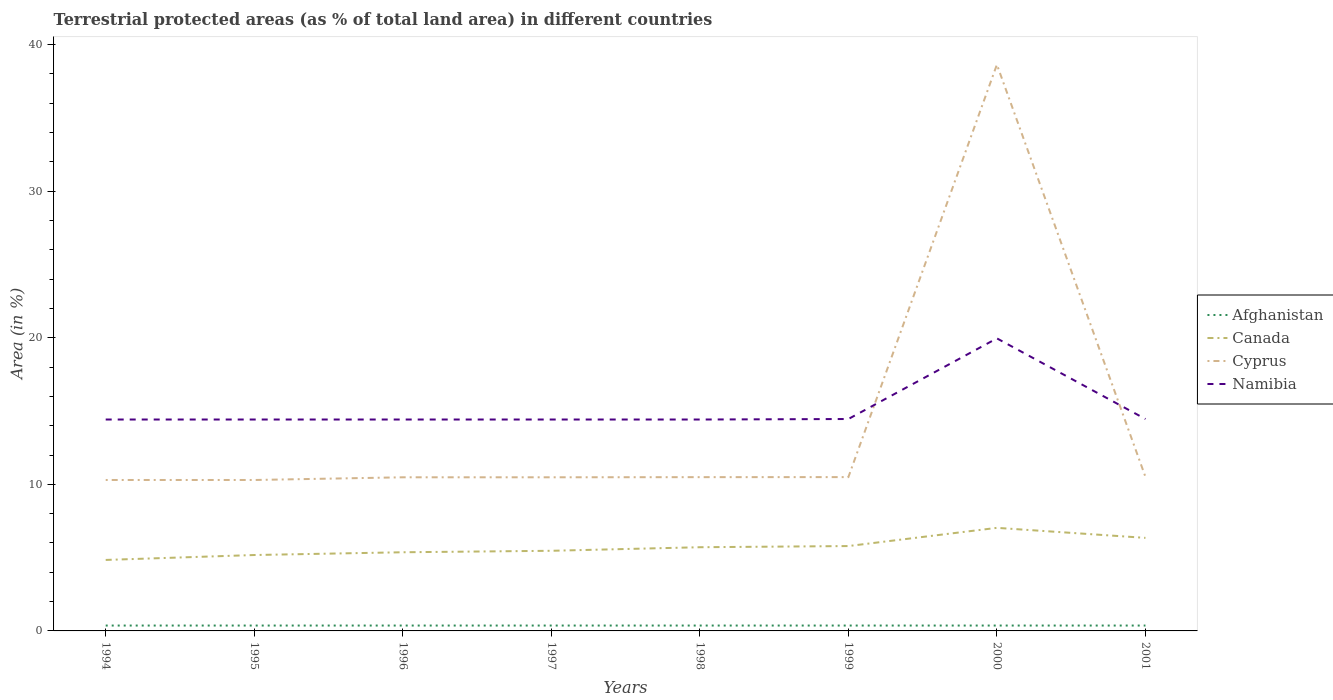Is the number of lines equal to the number of legend labels?
Your response must be concise. Yes. Across all years, what is the maximum percentage of terrestrial protected land in Cyprus?
Your answer should be compact. 10.3. In which year was the percentage of terrestrial protected land in Canada maximum?
Offer a very short reply. 1994. What is the total percentage of terrestrial protected land in Namibia in the graph?
Provide a short and direct response. -0.03. What is the difference between the highest and the second highest percentage of terrestrial protected land in Canada?
Ensure brevity in your answer.  2.19. Is the percentage of terrestrial protected land in Cyprus strictly greater than the percentage of terrestrial protected land in Namibia over the years?
Make the answer very short. No. How many years are there in the graph?
Give a very brief answer. 8. What is the difference between two consecutive major ticks on the Y-axis?
Your response must be concise. 10. Does the graph contain grids?
Offer a very short reply. No. Where does the legend appear in the graph?
Your answer should be compact. Center right. How are the legend labels stacked?
Provide a short and direct response. Vertical. What is the title of the graph?
Ensure brevity in your answer.  Terrestrial protected areas (as % of total land area) in different countries. Does "Myanmar" appear as one of the legend labels in the graph?
Your answer should be compact. No. What is the label or title of the Y-axis?
Make the answer very short. Area (in %). What is the Area (in %) in Afghanistan in 1994?
Provide a short and direct response. 0.37. What is the Area (in %) of Canada in 1994?
Offer a very short reply. 4.84. What is the Area (in %) of Cyprus in 1994?
Offer a terse response. 10.3. What is the Area (in %) of Namibia in 1994?
Provide a succinct answer. 14.42. What is the Area (in %) of Afghanistan in 1995?
Provide a succinct answer. 0.37. What is the Area (in %) in Canada in 1995?
Provide a short and direct response. 5.18. What is the Area (in %) in Cyprus in 1995?
Your answer should be very brief. 10.3. What is the Area (in %) in Namibia in 1995?
Give a very brief answer. 14.42. What is the Area (in %) of Afghanistan in 1996?
Provide a short and direct response. 0.37. What is the Area (in %) in Canada in 1996?
Offer a very short reply. 5.37. What is the Area (in %) of Cyprus in 1996?
Make the answer very short. 10.48. What is the Area (in %) of Namibia in 1996?
Keep it short and to the point. 14.42. What is the Area (in %) in Afghanistan in 1997?
Your answer should be very brief. 0.37. What is the Area (in %) in Canada in 1997?
Offer a very short reply. 5.47. What is the Area (in %) in Cyprus in 1997?
Give a very brief answer. 10.48. What is the Area (in %) in Namibia in 1997?
Offer a terse response. 14.42. What is the Area (in %) in Afghanistan in 1998?
Ensure brevity in your answer.  0.37. What is the Area (in %) in Canada in 1998?
Give a very brief answer. 5.71. What is the Area (in %) of Cyprus in 1998?
Your response must be concise. 10.49. What is the Area (in %) of Namibia in 1998?
Ensure brevity in your answer.  14.42. What is the Area (in %) of Afghanistan in 1999?
Your response must be concise. 0.37. What is the Area (in %) of Canada in 1999?
Offer a terse response. 5.79. What is the Area (in %) of Cyprus in 1999?
Provide a short and direct response. 10.49. What is the Area (in %) of Namibia in 1999?
Offer a terse response. 14.46. What is the Area (in %) of Afghanistan in 2000?
Your response must be concise. 0.37. What is the Area (in %) of Canada in 2000?
Make the answer very short. 7.03. What is the Area (in %) of Cyprus in 2000?
Ensure brevity in your answer.  38.63. What is the Area (in %) in Namibia in 2000?
Keep it short and to the point. 19.96. What is the Area (in %) of Afghanistan in 2001?
Ensure brevity in your answer.  0.37. What is the Area (in %) of Canada in 2001?
Your answer should be compact. 6.35. What is the Area (in %) in Cyprus in 2001?
Your answer should be very brief. 10.51. What is the Area (in %) in Namibia in 2001?
Provide a short and direct response. 14.46. Across all years, what is the maximum Area (in %) of Afghanistan?
Provide a short and direct response. 0.37. Across all years, what is the maximum Area (in %) in Canada?
Your response must be concise. 7.03. Across all years, what is the maximum Area (in %) of Cyprus?
Provide a short and direct response. 38.63. Across all years, what is the maximum Area (in %) in Namibia?
Provide a short and direct response. 19.96. Across all years, what is the minimum Area (in %) in Afghanistan?
Keep it short and to the point. 0.37. Across all years, what is the minimum Area (in %) in Canada?
Give a very brief answer. 4.84. Across all years, what is the minimum Area (in %) of Cyprus?
Offer a terse response. 10.3. Across all years, what is the minimum Area (in %) in Namibia?
Provide a succinct answer. 14.42. What is the total Area (in %) of Afghanistan in the graph?
Make the answer very short. 2.94. What is the total Area (in %) of Canada in the graph?
Offer a very short reply. 45.73. What is the total Area (in %) in Cyprus in the graph?
Keep it short and to the point. 111.67. What is the total Area (in %) in Namibia in the graph?
Your answer should be compact. 120.97. What is the difference between the Area (in %) of Canada in 1994 and that in 1995?
Provide a succinct answer. -0.34. What is the difference between the Area (in %) in Afghanistan in 1994 and that in 1996?
Ensure brevity in your answer.  0. What is the difference between the Area (in %) in Canada in 1994 and that in 1996?
Make the answer very short. -0.52. What is the difference between the Area (in %) of Cyprus in 1994 and that in 1996?
Provide a short and direct response. -0.18. What is the difference between the Area (in %) of Afghanistan in 1994 and that in 1997?
Offer a terse response. 0. What is the difference between the Area (in %) in Canada in 1994 and that in 1997?
Offer a terse response. -0.62. What is the difference between the Area (in %) of Cyprus in 1994 and that in 1997?
Your answer should be very brief. -0.18. What is the difference between the Area (in %) of Afghanistan in 1994 and that in 1998?
Offer a very short reply. 0. What is the difference between the Area (in %) of Canada in 1994 and that in 1998?
Give a very brief answer. -0.87. What is the difference between the Area (in %) of Cyprus in 1994 and that in 1998?
Keep it short and to the point. -0.19. What is the difference between the Area (in %) in Namibia in 1994 and that in 1998?
Offer a terse response. 0. What is the difference between the Area (in %) of Canada in 1994 and that in 1999?
Your answer should be very brief. -0.95. What is the difference between the Area (in %) in Cyprus in 1994 and that in 1999?
Ensure brevity in your answer.  -0.2. What is the difference between the Area (in %) of Namibia in 1994 and that in 1999?
Ensure brevity in your answer.  -0.03. What is the difference between the Area (in %) in Afghanistan in 1994 and that in 2000?
Keep it short and to the point. -0. What is the difference between the Area (in %) of Canada in 1994 and that in 2000?
Offer a terse response. -2.19. What is the difference between the Area (in %) in Cyprus in 1994 and that in 2000?
Keep it short and to the point. -28.33. What is the difference between the Area (in %) of Namibia in 1994 and that in 2000?
Your response must be concise. -5.54. What is the difference between the Area (in %) in Afghanistan in 1994 and that in 2001?
Your answer should be compact. 0. What is the difference between the Area (in %) of Canada in 1994 and that in 2001?
Provide a succinct answer. -1.51. What is the difference between the Area (in %) of Cyprus in 1994 and that in 2001?
Provide a succinct answer. -0.21. What is the difference between the Area (in %) in Namibia in 1994 and that in 2001?
Your answer should be compact. -0.03. What is the difference between the Area (in %) in Afghanistan in 1995 and that in 1996?
Offer a terse response. 0. What is the difference between the Area (in %) of Canada in 1995 and that in 1996?
Provide a short and direct response. -0.19. What is the difference between the Area (in %) of Cyprus in 1995 and that in 1996?
Make the answer very short. -0.18. What is the difference between the Area (in %) of Afghanistan in 1995 and that in 1997?
Offer a very short reply. 0. What is the difference between the Area (in %) of Canada in 1995 and that in 1997?
Make the answer very short. -0.29. What is the difference between the Area (in %) of Cyprus in 1995 and that in 1997?
Offer a very short reply. -0.18. What is the difference between the Area (in %) in Afghanistan in 1995 and that in 1998?
Keep it short and to the point. 0. What is the difference between the Area (in %) of Canada in 1995 and that in 1998?
Your response must be concise. -0.53. What is the difference between the Area (in %) in Cyprus in 1995 and that in 1998?
Your answer should be very brief. -0.19. What is the difference between the Area (in %) of Namibia in 1995 and that in 1998?
Provide a succinct answer. 0. What is the difference between the Area (in %) in Afghanistan in 1995 and that in 1999?
Your answer should be very brief. 0. What is the difference between the Area (in %) of Canada in 1995 and that in 1999?
Ensure brevity in your answer.  -0.61. What is the difference between the Area (in %) of Cyprus in 1995 and that in 1999?
Your answer should be very brief. -0.2. What is the difference between the Area (in %) of Namibia in 1995 and that in 1999?
Make the answer very short. -0.03. What is the difference between the Area (in %) in Canada in 1995 and that in 2000?
Make the answer very short. -1.85. What is the difference between the Area (in %) of Cyprus in 1995 and that in 2000?
Provide a short and direct response. -28.33. What is the difference between the Area (in %) of Namibia in 1995 and that in 2000?
Make the answer very short. -5.54. What is the difference between the Area (in %) in Canada in 1995 and that in 2001?
Ensure brevity in your answer.  -1.17. What is the difference between the Area (in %) in Cyprus in 1995 and that in 2001?
Your response must be concise. -0.21. What is the difference between the Area (in %) of Namibia in 1995 and that in 2001?
Ensure brevity in your answer.  -0.03. What is the difference between the Area (in %) in Afghanistan in 1996 and that in 1997?
Your answer should be very brief. 0. What is the difference between the Area (in %) of Canada in 1996 and that in 1997?
Your answer should be very brief. -0.1. What is the difference between the Area (in %) in Cyprus in 1996 and that in 1997?
Offer a terse response. 0. What is the difference between the Area (in %) in Namibia in 1996 and that in 1997?
Your response must be concise. 0. What is the difference between the Area (in %) in Afghanistan in 1996 and that in 1998?
Offer a very short reply. 0. What is the difference between the Area (in %) of Canada in 1996 and that in 1998?
Make the answer very short. -0.34. What is the difference between the Area (in %) in Cyprus in 1996 and that in 1998?
Provide a short and direct response. -0.01. What is the difference between the Area (in %) of Afghanistan in 1996 and that in 1999?
Your response must be concise. 0. What is the difference between the Area (in %) in Canada in 1996 and that in 1999?
Offer a very short reply. -0.42. What is the difference between the Area (in %) in Cyprus in 1996 and that in 1999?
Provide a short and direct response. -0.01. What is the difference between the Area (in %) of Namibia in 1996 and that in 1999?
Provide a short and direct response. -0.03. What is the difference between the Area (in %) of Afghanistan in 1996 and that in 2000?
Keep it short and to the point. -0. What is the difference between the Area (in %) in Canada in 1996 and that in 2000?
Your response must be concise. -1.67. What is the difference between the Area (in %) in Cyprus in 1996 and that in 2000?
Give a very brief answer. -28.15. What is the difference between the Area (in %) of Namibia in 1996 and that in 2000?
Ensure brevity in your answer.  -5.54. What is the difference between the Area (in %) in Canada in 1996 and that in 2001?
Offer a very short reply. -0.98. What is the difference between the Area (in %) of Cyprus in 1996 and that in 2001?
Provide a short and direct response. -0.03. What is the difference between the Area (in %) of Namibia in 1996 and that in 2001?
Offer a very short reply. -0.03. What is the difference between the Area (in %) in Afghanistan in 1997 and that in 1998?
Provide a succinct answer. 0. What is the difference between the Area (in %) in Canada in 1997 and that in 1998?
Your response must be concise. -0.24. What is the difference between the Area (in %) in Cyprus in 1997 and that in 1998?
Make the answer very short. -0.01. What is the difference between the Area (in %) of Canada in 1997 and that in 1999?
Make the answer very short. -0.32. What is the difference between the Area (in %) in Cyprus in 1997 and that in 1999?
Provide a succinct answer. -0.01. What is the difference between the Area (in %) in Namibia in 1997 and that in 1999?
Provide a succinct answer. -0.03. What is the difference between the Area (in %) in Canada in 1997 and that in 2000?
Make the answer very short. -1.56. What is the difference between the Area (in %) in Cyprus in 1997 and that in 2000?
Ensure brevity in your answer.  -28.15. What is the difference between the Area (in %) in Namibia in 1997 and that in 2000?
Give a very brief answer. -5.54. What is the difference between the Area (in %) of Afghanistan in 1997 and that in 2001?
Provide a short and direct response. 0. What is the difference between the Area (in %) in Canada in 1997 and that in 2001?
Your answer should be very brief. -0.88. What is the difference between the Area (in %) in Cyprus in 1997 and that in 2001?
Keep it short and to the point. -0.03. What is the difference between the Area (in %) in Namibia in 1997 and that in 2001?
Provide a short and direct response. -0.03. What is the difference between the Area (in %) of Afghanistan in 1998 and that in 1999?
Make the answer very short. 0. What is the difference between the Area (in %) in Canada in 1998 and that in 1999?
Provide a succinct answer. -0.08. What is the difference between the Area (in %) in Cyprus in 1998 and that in 1999?
Offer a terse response. -0. What is the difference between the Area (in %) in Namibia in 1998 and that in 1999?
Your response must be concise. -0.03. What is the difference between the Area (in %) in Canada in 1998 and that in 2000?
Your answer should be very brief. -1.32. What is the difference between the Area (in %) in Cyprus in 1998 and that in 2000?
Provide a succinct answer. -28.14. What is the difference between the Area (in %) in Namibia in 1998 and that in 2000?
Your answer should be compact. -5.54. What is the difference between the Area (in %) of Afghanistan in 1998 and that in 2001?
Keep it short and to the point. 0. What is the difference between the Area (in %) in Canada in 1998 and that in 2001?
Your response must be concise. -0.64. What is the difference between the Area (in %) of Cyprus in 1998 and that in 2001?
Your answer should be very brief. -0.02. What is the difference between the Area (in %) of Namibia in 1998 and that in 2001?
Provide a short and direct response. -0.03. What is the difference between the Area (in %) of Afghanistan in 1999 and that in 2000?
Your answer should be very brief. -0. What is the difference between the Area (in %) in Canada in 1999 and that in 2000?
Give a very brief answer. -1.24. What is the difference between the Area (in %) of Cyprus in 1999 and that in 2000?
Provide a short and direct response. -28.14. What is the difference between the Area (in %) in Namibia in 1999 and that in 2000?
Your answer should be very brief. -5.5. What is the difference between the Area (in %) in Canada in 1999 and that in 2001?
Offer a terse response. -0.56. What is the difference between the Area (in %) of Cyprus in 1999 and that in 2001?
Your answer should be compact. -0.02. What is the difference between the Area (in %) in Namibia in 1999 and that in 2001?
Your answer should be very brief. 0. What is the difference between the Area (in %) in Canada in 2000 and that in 2001?
Offer a terse response. 0.68. What is the difference between the Area (in %) in Cyprus in 2000 and that in 2001?
Your answer should be very brief. 28.12. What is the difference between the Area (in %) in Namibia in 2000 and that in 2001?
Your answer should be very brief. 5.5. What is the difference between the Area (in %) of Afghanistan in 1994 and the Area (in %) of Canada in 1995?
Make the answer very short. -4.81. What is the difference between the Area (in %) of Afghanistan in 1994 and the Area (in %) of Cyprus in 1995?
Provide a succinct answer. -9.93. What is the difference between the Area (in %) of Afghanistan in 1994 and the Area (in %) of Namibia in 1995?
Provide a short and direct response. -14.05. What is the difference between the Area (in %) of Canada in 1994 and the Area (in %) of Cyprus in 1995?
Your answer should be compact. -5.45. What is the difference between the Area (in %) of Canada in 1994 and the Area (in %) of Namibia in 1995?
Ensure brevity in your answer.  -9.58. What is the difference between the Area (in %) of Cyprus in 1994 and the Area (in %) of Namibia in 1995?
Keep it short and to the point. -4.12. What is the difference between the Area (in %) in Afghanistan in 1994 and the Area (in %) in Canada in 1996?
Your answer should be very brief. -5. What is the difference between the Area (in %) in Afghanistan in 1994 and the Area (in %) in Cyprus in 1996?
Provide a succinct answer. -10.11. What is the difference between the Area (in %) of Afghanistan in 1994 and the Area (in %) of Namibia in 1996?
Provide a succinct answer. -14.05. What is the difference between the Area (in %) of Canada in 1994 and the Area (in %) of Cyprus in 1996?
Ensure brevity in your answer.  -5.64. What is the difference between the Area (in %) of Canada in 1994 and the Area (in %) of Namibia in 1996?
Your answer should be compact. -9.58. What is the difference between the Area (in %) in Cyprus in 1994 and the Area (in %) in Namibia in 1996?
Provide a short and direct response. -4.12. What is the difference between the Area (in %) of Afghanistan in 1994 and the Area (in %) of Canada in 1997?
Keep it short and to the point. -5.1. What is the difference between the Area (in %) of Afghanistan in 1994 and the Area (in %) of Cyprus in 1997?
Your answer should be compact. -10.11. What is the difference between the Area (in %) of Afghanistan in 1994 and the Area (in %) of Namibia in 1997?
Make the answer very short. -14.05. What is the difference between the Area (in %) of Canada in 1994 and the Area (in %) of Cyprus in 1997?
Your answer should be very brief. -5.64. What is the difference between the Area (in %) of Canada in 1994 and the Area (in %) of Namibia in 1997?
Your response must be concise. -9.58. What is the difference between the Area (in %) of Cyprus in 1994 and the Area (in %) of Namibia in 1997?
Ensure brevity in your answer.  -4.12. What is the difference between the Area (in %) of Afghanistan in 1994 and the Area (in %) of Canada in 1998?
Provide a short and direct response. -5.34. What is the difference between the Area (in %) of Afghanistan in 1994 and the Area (in %) of Cyprus in 1998?
Your answer should be compact. -10.12. What is the difference between the Area (in %) in Afghanistan in 1994 and the Area (in %) in Namibia in 1998?
Make the answer very short. -14.05. What is the difference between the Area (in %) of Canada in 1994 and the Area (in %) of Cyprus in 1998?
Your answer should be very brief. -5.65. What is the difference between the Area (in %) in Canada in 1994 and the Area (in %) in Namibia in 1998?
Your response must be concise. -9.58. What is the difference between the Area (in %) in Cyprus in 1994 and the Area (in %) in Namibia in 1998?
Ensure brevity in your answer.  -4.12. What is the difference between the Area (in %) in Afghanistan in 1994 and the Area (in %) in Canada in 1999?
Your response must be concise. -5.42. What is the difference between the Area (in %) in Afghanistan in 1994 and the Area (in %) in Cyprus in 1999?
Keep it short and to the point. -10.13. What is the difference between the Area (in %) of Afghanistan in 1994 and the Area (in %) of Namibia in 1999?
Make the answer very short. -14.09. What is the difference between the Area (in %) in Canada in 1994 and the Area (in %) in Cyprus in 1999?
Your answer should be very brief. -5.65. What is the difference between the Area (in %) in Canada in 1994 and the Area (in %) in Namibia in 1999?
Your answer should be very brief. -9.61. What is the difference between the Area (in %) of Cyprus in 1994 and the Area (in %) of Namibia in 1999?
Ensure brevity in your answer.  -4.16. What is the difference between the Area (in %) in Afghanistan in 1994 and the Area (in %) in Canada in 2000?
Provide a succinct answer. -6.66. What is the difference between the Area (in %) of Afghanistan in 1994 and the Area (in %) of Cyprus in 2000?
Give a very brief answer. -38.26. What is the difference between the Area (in %) in Afghanistan in 1994 and the Area (in %) in Namibia in 2000?
Your answer should be compact. -19.59. What is the difference between the Area (in %) of Canada in 1994 and the Area (in %) of Cyprus in 2000?
Give a very brief answer. -33.79. What is the difference between the Area (in %) of Canada in 1994 and the Area (in %) of Namibia in 2000?
Your answer should be very brief. -15.11. What is the difference between the Area (in %) of Cyprus in 1994 and the Area (in %) of Namibia in 2000?
Keep it short and to the point. -9.66. What is the difference between the Area (in %) in Afghanistan in 1994 and the Area (in %) in Canada in 2001?
Provide a short and direct response. -5.98. What is the difference between the Area (in %) of Afghanistan in 1994 and the Area (in %) of Cyprus in 2001?
Offer a very short reply. -10.14. What is the difference between the Area (in %) of Afghanistan in 1994 and the Area (in %) of Namibia in 2001?
Your answer should be very brief. -14.09. What is the difference between the Area (in %) in Canada in 1994 and the Area (in %) in Cyprus in 2001?
Provide a succinct answer. -5.67. What is the difference between the Area (in %) in Canada in 1994 and the Area (in %) in Namibia in 2001?
Your answer should be compact. -9.61. What is the difference between the Area (in %) of Cyprus in 1994 and the Area (in %) of Namibia in 2001?
Provide a short and direct response. -4.16. What is the difference between the Area (in %) of Afghanistan in 1995 and the Area (in %) of Canada in 1996?
Make the answer very short. -5. What is the difference between the Area (in %) of Afghanistan in 1995 and the Area (in %) of Cyprus in 1996?
Keep it short and to the point. -10.11. What is the difference between the Area (in %) in Afghanistan in 1995 and the Area (in %) in Namibia in 1996?
Give a very brief answer. -14.05. What is the difference between the Area (in %) of Canada in 1995 and the Area (in %) of Cyprus in 1996?
Offer a terse response. -5.3. What is the difference between the Area (in %) of Canada in 1995 and the Area (in %) of Namibia in 1996?
Provide a succinct answer. -9.24. What is the difference between the Area (in %) in Cyprus in 1995 and the Area (in %) in Namibia in 1996?
Provide a succinct answer. -4.12. What is the difference between the Area (in %) of Afghanistan in 1995 and the Area (in %) of Canada in 1997?
Provide a short and direct response. -5.1. What is the difference between the Area (in %) of Afghanistan in 1995 and the Area (in %) of Cyprus in 1997?
Your response must be concise. -10.11. What is the difference between the Area (in %) of Afghanistan in 1995 and the Area (in %) of Namibia in 1997?
Provide a succinct answer. -14.05. What is the difference between the Area (in %) of Canada in 1995 and the Area (in %) of Cyprus in 1997?
Give a very brief answer. -5.3. What is the difference between the Area (in %) in Canada in 1995 and the Area (in %) in Namibia in 1997?
Offer a terse response. -9.24. What is the difference between the Area (in %) of Cyprus in 1995 and the Area (in %) of Namibia in 1997?
Ensure brevity in your answer.  -4.12. What is the difference between the Area (in %) of Afghanistan in 1995 and the Area (in %) of Canada in 1998?
Ensure brevity in your answer.  -5.34. What is the difference between the Area (in %) in Afghanistan in 1995 and the Area (in %) in Cyprus in 1998?
Your answer should be compact. -10.12. What is the difference between the Area (in %) of Afghanistan in 1995 and the Area (in %) of Namibia in 1998?
Your answer should be compact. -14.05. What is the difference between the Area (in %) in Canada in 1995 and the Area (in %) in Cyprus in 1998?
Keep it short and to the point. -5.31. What is the difference between the Area (in %) in Canada in 1995 and the Area (in %) in Namibia in 1998?
Offer a very short reply. -9.24. What is the difference between the Area (in %) in Cyprus in 1995 and the Area (in %) in Namibia in 1998?
Offer a very short reply. -4.12. What is the difference between the Area (in %) in Afghanistan in 1995 and the Area (in %) in Canada in 1999?
Your answer should be very brief. -5.42. What is the difference between the Area (in %) of Afghanistan in 1995 and the Area (in %) of Cyprus in 1999?
Provide a succinct answer. -10.13. What is the difference between the Area (in %) in Afghanistan in 1995 and the Area (in %) in Namibia in 1999?
Keep it short and to the point. -14.09. What is the difference between the Area (in %) in Canada in 1995 and the Area (in %) in Cyprus in 1999?
Keep it short and to the point. -5.31. What is the difference between the Area (in %) in Canada in 1995 and the Area (in %) in Namibia in 1999?
Your response must be concise. -9.28. What is the difference between the Area (in %) in Cyprus in 1995 and the Area (in %) in Namibia in 1999?
Give a very brief answer. -4.16. What is the difference between the Area (in %) of Afghanistan in 1995 and the Area (in %) of Canada in 2000?
Your answer should be compact. -6.66. What is the difference between the Area (in %) of Afghanistan in 1995 and the Area (in %) of Cyprus in 2000?
Keep it short and to the point. -38.26. What is the difference between the Area (in %) in Afghanistan in 1995 and the Area (in %) in Namibia in 2000?
Offer a very short reply. -19.59. What is the difference between the Area (in %) of Canada in 1995 and the Area (in %) of Cyprus in 2000?
Keep it short and to the point. -33.45. What is the difference between the Area (in %) in Canada in 1995 and the Area (in %) in Namibia in 2000?
Offer a very short reply. -14.78. What is the difference between the Area (in %) in Cyprus in 1995 and the Area (in %) in Namibia in 2000?
Provide a succinct answer. -9.66. What is the difference between the Area (in %) in Afghanistan in 1995 and the Area (in %) in Canada in 2001?
Offer a terse response. -5.98. What is the difference between the Area (in %) of Afghanistan in 1995 and the Area (in %) of Cyprus in 2001?
Offer a very short reply. -10.14. What is the difference between the Area (in %) of Afghanistan in 1995 and the Area (in %) of Namibia in 2001?
Provide a succinct answer. -14.09. What is the difference between the Area (in %) of Canada in 1995 and the Area (in %) of Cyprus in 2001?
Provide a succinct answer. -5.33. What is the difference between the Area (in %) of Canada in 1995 and the Area (in %) of Namibia in 2001?
Give a very brief answer. -9.28. What is the difference between the Area (in %) of Cyprus in 1995 and the Area (in %) of Namibia in 2001?
Your answer should be compact. -4.16. What is the difference between the Area (in %) of Afghanistan in 1996 and the Area (in %) of Canada in 1997?
Your answer should be very brief. -5.1. What is the difference between the Area (in %) in Afghanistan in 1996 and the Area (in %) in Cyprus in 1997?
Offer a terse response. -10.11. What is the difference between the Area (in %) in Afghanistan in 1996 and the Area (in %) in Namibia in 1997?
Ensure brevity in your answer.  -14.05. What is the difference between the Area (in %) in Canada in 1996 and the Area (in %) in Cyprus in 1997?
Give a very brief answer. -5.11. What is the difference between the Area (in %) in Canada in 1996 and the Area (in %) in Namibia in 1997?
Give a very brief answer. -9.05. What is the difference between the Area (in %) of Cyprus in 1996 and the Area (in %) of Namibia in 1997?
Keep it short and to the point. -3.94. What is the difference between the Area (in %) of Afghanistan in 1996 and the Area (in %) of Canada in 1998?
Ensure brevity in your answer.  -5.34. What is the difference between the Area (in %) of Afghanistan in 1996 and the Area (in %) of Cyprus in 1998?
Make the answer very short. -10.12. What is the difference between the Area (in %) of Afghanistan in 1996 and the Area (in %) of Namibia in 1998?
Offer a very short reply. -14.05. What is the difference between the Area (in %) of Canada in 1996 and the Area (in %) of Cyprus in 1998?
Offer a terse response. -5.12. What is the difference between the Area (in %) of Canada in 1996 and the Area (in %) of Namibia in 1998?
Your response must be concise. -9.05. What is the difference between the Area (in %) in Cyprus in 1996 and the Area (in %) in Namibia in 1998?
Make the answer very short. -3.94. What is the difference between the Area (in %) in Afghanistan in 1996 and the Area (in %) in Canada in 1999?
Provide a succinct answer. -5.42. What is the difference between the Area (in %) in Afghanistan in 1996 and the Area (in %) in Cyprus in 1999?
Make the answer very short. -10.13. What is the difference between the Area (in %) of Afghanistan in 1996 and the Area (in %) of Namibia in 1999?
Ensure brevity in your answer.  -14.09. What is the difference between the Area (in %) of Canada in 1996 and the Area (in %) of Cyprus in 1999?
Offer a terse response. -5.13. What is the difference between the Area (in %) in Canada in 1996 and the Area (in %) in Namibia in 1999?
Make the answer very short. -9.09. What is the difference between the Area (in %) of Cyprus in 1996 and the Area (in %) of Namibia in 1999?
Ensure brevity in your answer.  -3.98. What is the difference between the Area (in %) of Afghanistan in 1996 and the Area (in %) of Canada in 2000?
Ensure brevity in your answer.  -6.66. What is the difference between the Area (in %) of Afghanistan in 1996 and the Area (in %) of Cyprus in 2000?
Offer a terse response. -38.26. What is the difference between the Area (in %) in Afghanistan in 1996 and the Area (in %) in Namibia in 2000?
Make the answer very short. -19.59. What is the difference between the Area (in %) of Canada in 1996 and the Area (in %) of Cyprus in 2000?
Keep it short and to the point. -33.26. What is the difference between the Area (in %) in Canada in 1996 and the Area (in %) in Namibia in 2000?
Offer a very short reply. -14.59. What is the difference between the Area (in %) of Cyprus in 1996 and the Area (in %) of Namibia in 2000?
Give a very brief answer. -9.48. What is the difference between the Area (in %) of Afghanistan in 1996 and the Area (in %) of Canada in 2001?
Ensure brevity in your answer.  -5.98. What is the difference between the Area (in %) of Afghanistan in 1996 and the Area (in %) of Cyprus in 2001?
Provide a short and direct response. -10.14. What is the difference between the Area (in %) of Afghanistan in 1996 and the Area (in %) of Namibia in 2001?
Offer a terse response. -14.09. What is the difference between the Area (in %) of Canada in 1996 and the Area (in %) of Cyprus in 2001?
Provide a succinct answer. -5.14. What is the difference between the Area (in %) of Canada in 1996 and the Area (in %) of Namibia in 2001?
Keep it short and to the point. -9.09. What is the difference between the Area (in %) of Cyprus in 1996 and the Area (in %) of Namibia in 2001?
Offer a very short reply. -3.98. What is the difference between the Area (in %) in Afghanistan in 1997 and the Area (in %) in Canada in 1998?
Keep it short and to the point. -5.34. What is the difference between the Area (in %) of Afghanistan in 1997 and the Area (in %) of Cyprus in 1998?
Your answer should be compact. -10.12. What is the difference between the Area (in %) of Afghanistan in 1997 and the Area (in %) of Namibia in 1998?
Your answer should be compact. -14.05. What is the difference between the Area (in %) of Canada in 1997 and the Area (in %) of Cyprus in 1998?
Make the answer very short. -5.02. What is the difference between the Area (in %) in Canada in 1997 and the Area (in %) in Namibia in 1998?
Your answer should be compact. -8.95. What is the difference between the Area (in %) of Cyprus in 1997 and the Area (in %) of Namibia in 1998?
Your answer should be compact. -3.94. What is the difference between the Area (in %) in Afghanistan in 1997 and the Area (in %) in Canada in 1999?
Offer a very short reply. -5.42. What is the difference between the Area (in %) in Afghanistan in 1997 and the Area (in %) in Cyprus in 1999?
Your answer should be compact. -10.13. What is the difference between the Area (in %) in Afghanistan in 1997 and the Area (in %) in Namibia in 1999?
Make the answer very short. -14.09. What is the difference between the Area (in %) of Canada in 1997 and the Area (in %) of Cyprus in 1999?
Ensure brevity in your answer.  -5.03. What is the difference between the Area (in %) in Canada in 1997 and the Area (in %) in Namibia in 1999?
Offer a very short reply. -8.99. What is the difference between the Area (in %) in Cyprus in 1997 and the Area (in %) in Namibia in 1999?
Your answer should be very brief. -3.98. What is the difference between the Area (in %) of Afghanistan in 1997 and the Area (in %) of Canada in 2000?
Ensure brevity in your answer.  -6.66. What is the difference between the Area (in %) of Afghanistan in 1997 and the Area (in %) of Cyprus in 2000?
Your response must be concise. -38.26. What is the difference between the Area (in %) in Afghanistan in 1997 and the Area (in %) in Namibia in 2000?
Keep it short and to the point. -19.59. What is the difference between the Area (in %) in Canada in 1997 and the Area (in %) in Cyprus in 2000?
Ensure brevity in your answer.  -33.16. What is the difference between the Area (in %) in Canada in 1997 and the Area (in %) in Namibia in 2000?
Offer a terse response. -14.49. What is the difference between the Area (in %) of Cyprus in 1997 and the Area (in %) of Namibia in 2000?
Your response must be concise. -9.48. What is the difference between the Area (in %) in Afghanistan in 1997 and the Area (in %) in Canada in 2001?
Your answer should be very brief. -5.98. What is the difference between the Area (in %) in Afghanistan in 1997 and the Area (in %) in Cyprus in 2001?
Give a very brief answer. -10.14. What is the difference between the Area (in %) of Afghanistan in 1997 and the Area (in %) of Namibia in 2001?
Your response must be concise. -14.09. What is the difference between the Area (in %) of Canada in 1997 and the Area (in %) of Cyprus in 2001?
Give a very brief answer. -5.04. What is the difference between the Area (in %) of Canada in 1997 and the Area (in %) of Namibia in 2001?
Keep it short and to the point. -8.99. What is the difference between the Area (in %) in Cyprus in 1997 and the Area (in %) in Namibia in 2001?
Give a very brief answer. -3.98. What is the difference between the Area (in %) of Afghanistan in 1998 and the Area (in %) of Canada in 1999?
Provide a short and direct response. -5.42. What is the difference between the Area (in %) of Afghanistan in 1998 and the Area (in %) of Cyprus in 1999?
Ensure brevity in your answer.  -10.13. What is the difference between the Area (in %) in Afghanistan in 1998 and the Area (in %) in Namibia in 1999?
Provide a succinct answer. -14.09. What is the difference between the Area (in %) of Canada in 1998 and the Area (in %) of Cyprus in 1999?
Provide a succinct answer. -4.78. What is the difference between the Area (in %) of Canada in 1998 and the Area (in %) of Namibia in 1999?
Ensure brevity in your answer.  -8.75. What is the difference between the Area (in %) in Cyprus in 1998 and the Area (in %) in Namibia in 1999?
Your answer should be compact. -3.97. What is the difference between the Area (in %) in Afghanistan in 1998 and the Area (in %) in Canada in 2000?
Provide a short and direct response. -6.66. What is the difference between the Area (in %) of Afghanistan in 1998 and the Area (in %) of Cyprus in 2000?
Offer a terse response. -38.26. What is the difference between the Area (in %) of Afghanistan in 1998 and the Area (in %) of Namibia in 2000?
Ensure brevity in your answer.  -19.59. What is the difference between the Area (in %) of Canada in 1998 and the Area (in %) of Cyprus in 2000?
Offer a terse response. -32.92. What is the difference between the Area (in %) of Canada in 1998 and the Area (in %) of Namibia in 2000?
Your response must be concise. -14.25. What is the difference between the Area (in %) of Cyprus in 1998 and the Area (in %) of Namibia in 2000?
Offer a terse response. -9.47. What is the difference between the Area (in %) of Afghanistan in 1998 and the Area (in %) of Canada in 2001?
Make the answer very short. -5.98. What is the difference between the Area (in %) in Afghanistan in 1998 and the Area (in %) in Cyprus in 2001?
Offer a very short reply. -10.14. What is the difference between the Area (in %) in Afghanistan in 1998 and the Area (in %) in Namibia in 2001?
Your answer should be compact. -14.09. What is the difference between the Area (in %) of Canada in 1998 and the Area (in %) of Cyprus in 2001?
Your answer should be compact. -4.8. What is the difference between the Area (in %) of Canada in 1998 and the Area (in %) of Namibia in 2001?
Make the answer very short. -8.75. What is the difference between the Area (in %) of Cyprus in 1998 and the Area (in %) of Namibia in 2001?
Keep it short and to the point. -3.97. What is the difference between the Area (in %) of Afghanistan in 1999 and the Area (in %) of Canada in 2000?
Your answer should be very brief. -6.66. What is the difference between the Area (in %) of Afghanistan in 1999 and the Area (in %) of Cyprus in 2000?
Provide a short and direct response. -38.26. What is the difference between the Area (in %) of Afghanistan in 1999 and the Area (in %) of Namibia in 2000?
Provide a succinct answer. -19.59. What is the difference between the Area (in %) of Canada in 1999 and the Area (in %) of Cyprus in 2000?
Make the answer very short. -32.84. What is the difference between the Area (in %) in Canada in 1999 and the Area (in %) in Namibia in 2000?
Provide a succinct answer. -14.17. What is the difference between the Area (in %) in Cyprus in 1999 and the Area (in %) in Namibia in 2000?
Provide a short and direct response. -9.46. What is the difference between the Area (in %) of Afghanistan in 1999 and the Area (in %) of Canada in 2001?
Provide a succinct answer. -5.98. What is the difference between the Area (in %) in Afghanistan in 1999 and the Area (in %) in Cyprus in 2001?
Your response must be concise. -10.14. What is the difference between the Area (in %) of Afghanistan in 1999 and the Area (in %) of Namibia in 2001?
Your response must be concise. -14.09. What is the difference between the Area (in %) of Canada in 1999 and the Area (in %) of Cyprus in 2001?
Offer a terse response. -4.72. What is the difference between the Area (in %) in Canada in 1999 and the Area (in %) in Namibia in 2001?
Give a very brief answer. -8.67. What is the difference between the Area (in %) in Cyprus in 1999 and the Area (in %) in Namibia in 2001?
Make the answer very short. -3.96. What is the difference between the Area (in %) in Afghanistan in 2000 and the Area (in %) in Canada in 2001?
Your answer should be compact. -5.98. What is the difference between the Area (in %) in Afghanistan in 2000 and the Area (in %) in Cyprus in 2001?
Offer a very short reply. -10.14. What is the difference between the Area (in %) in Afghanistan in 2000 and the Area (in %) in Namibia in 2001?
Make the answer very short. -14.09. What is the difference between the Area (in %) of Canada in 2000 and the Area (in %) of Cyprus in 2001?
Make the answer very short. -3.48. What is the difference between the Area (in %) of Canada in 2000 and the Area (in %) of Namibia in 2001?
Ensure brevity in your answer.  -7.42. What is the difference between the Area (in %) in Cyprus in 2000 and the Area (in %) in Namibia in 2001?
Offer a terse response. 24.17. What is the average Area (in %) of Afghanistan per year?
Offer a very short reply. 0.37. What is the average Area (in %) of Canada per year?
Your answer should be compact. 5.72. What is the average Area (in %) of Cyprus per year?
Your answer should be compact. 13.96. What is the average Area (in %) of Namibia per year?
Provide a succinct answer. 15.12. In the year 1994, what is the difference between the Area (in %) in Afghanistan and Area (in %) in Canada?
Make the answer very short. -4.48. In the year 1994, what is the difference between the Area (in %) of Afghanistan and Area (in %) of Cyprus?
Offer a very short reply. -9.93. In the year 1994, what is the difference between the Area (in %) of Afghanistan and Area (in %) of Namibia?
Make the answer very short. -14.05. In the year 1994, what is the difference between the Area (in %) of Canada and Area (in %) of Cyprus?
Provide a short and direct response. -5.45. In the year 1994, what is the difference between the Area (in %) of Canada and Area (in %) of Namibia?
Provide a short and direct response. -9.58. In the year 1994, what is the difference between the Area (in %) of Cyprus and Area (in %) of Namibia?
Your response must be concise. -4.12. In the year 1995, what is the difference between the Area (in %) in Afghanistan and Area (in %) in Canada?
Offer a very short reply. -4.81. In the year 1995, what is the difference between the Area (in %) of Afghanistan and Area (in %) of Cyprus?
Provide a succinct answer. -9.93. In the year 1995, what is the difference between the Area (in %) in Afghanistan and Area (in %) in Namibia?
Provide a short and direct response. -14.05. In the year 1995, what is the difference between the Area (in %) of Canada and Area (in %) of Cyprus?
Keep it short and to the point. -5.12. In the year 1995, what is the difference between the Area (in %) in Canada and Area (in %) in Namibia?
Make the answer very short. -9.24. In the year 1995, what is the difference between the Area (in %) of Cyprus and Area (in %) of Namibia?
Keep it short and to the point. -4.12. In the year 1996, what is the difference between the Area (in %) in Afghanistan and Area (in %) in Canada?
Your answer should be compact. -5. In the year 1996, what is the difference between the Area (in %) in Afghanistan and Area (in %) in Cyprus?
Ensure brevity in your answer.  -10.11. In the year 1996, what is the difference between the Area (in %) of Afghanistan and Area (in %) of Namibia?
Offer a very short reply. -14.05. In the year 1996, what is the difference between the Area (in %) in Canada and Area (in %) in Cyprus?
Provide a succinct answer. -5.11. In the year 1996, what is the difference between the Area (in %) in Canada and Area (in %) in Namibia?
Your answer should be compact. -9.05. In the year 1996, what is the difference between the Area (in %) of Cyprus and Area (in %) of Namibia?
Provide a short and direct response. -3.94. In the year 1997, what is the difference between the Area (in %) in Afghanistan and Area (in %) in Canada?
Your response must be concise. -5.1. In the year 1997, what is the difference between the Area (in %) in Afghanistan and Area (in %) in Cyprus?
Your response must be concise. -10.11. In the year 1997, what is the difference between the Area (in %) of Afghanistan and Area (in %) of Namibia?
Provide a short and direct response. -14.05. In the year 1997, what is the difference between the Area (in %) in Canada and Area (in %) in Cyprus?
Your response must be concise. -5.01. In the year 1997, what is the difference between the Area (in %) in Canada and Area (in %) in Namibia?
Ensure brevity in your answer.  -8.95. In the year 1997, what is the difference between the Area (in %) of Cyprus and Area (in %) of Namibia?
Your answer should be compact. -3.94. In the year 1998, what is the difference between the Area (in %) in Afghanistan and Area (in %) in Canada?
Offer a very short reply. -5.34. In the year 1998, what is the difference between the Area (in %) in Afghanistan and Area (in %) in Cyprus?
Your response must be concise. -10.12. In the year 1998, what is the difference between the Area (in %) of Afghanistan and Area (in %) of Namibia?
Make the answer very short. -14.05. In the year 1998, what is the difference between the Area (in %) of Canada and Area (in %) of Cyprus?
Provide a succinct answer. -4.78. In the year 1998, what is the difference between the Area (in %) of Canada and Area (in %) of Namibia?
Your answer should be very brief. -8.71. In the year 1998, what is the difference between the Area (in %) of Cyprus and Area (in %) of Namibia?
Make the answer very short. -3.93. In the year 1999, what is the difference between the Area (in %) of Afghanistan and Area (in %) of Canada?
Provide a succinct answer. -5.42. In the year 1999, what is the difference between the Area (in %) of Afghanistan and Area (in %) of Cyprus?
Your response must be concise. -10.13. In the year 1999, what is the difference between the Area (in %) of Afghanistan and Area (in %) of Namibia?
Give a very brief answer. -14.09. In the year 1999, what is the difference between the Area (in %) in Canada and Area (in %) in Cyprus?
Keep it short and to the point. -4.7. In the year 1999, what is the difference between the Area (in %) in Canada and Area (in %) in Namibia?
Make the answer very short. -8.67. In the year 1999, what is the difference between the Area (in %) in Cyprus and Area (in %) in Namibia?
Keep it short and to the point. -3.96. In the year 2000, what is the difference between the Area (in %) in Afghanistan and Area (in %) in Canada?
Offer a terse response. -6.66. In the year 2000, what is the difference between the Area (in %) of Afghanistan and Area (in %) of Cyprus?
Your answer should be very brief. -38.26. In the year 2000, what is the difference between the Area (in %) of Afghanistan and Area (in %) of Namibia?
Offer a terse response. -19.59. In the year 2000, what is the difference between the Area (in %) of Canada and Area (in %) of Cyprus?
Provide a succinct answer. -31.6. In the year 2000, what is the difference between the Area (in %) in Canada and Area (in %) in Namibia?
Your answer should be compact. -12.92. In the year 2000, what is the difference between the Area (in %) of Cyprus and Area (in %) of Namibia?
Give a very brief answer. 18.67. In the year 2001, what is the difference between the Area (in %) in Afghanistan and Area (in %) in Canada?
Give a very brief answer. -5.98. In the year 2001, what is the difference between the Area (in %) of Afghanistan and Area (in %) of Cyprus?
Your response must be concise. -10.14. In the year 2001, what is the difference between the Area (in %) in Afghanistan and Area (in %) in Namibia?
Make the answer very short. -14.09. In the year 2001, what is the difference between the Area (in %) of Canada and Area (in %) of Cyprus?
Your answer should be very brief. -4.16. In the year 2001, what is the difference between the Area (in %) in Canada and Area (in %) in Namibia?
Provide a succinct answer. -8.11. In the year 2001, what is the difference between the Area (in %) of Cyprus and Area (in %) of Namibia?
Offer a very short reply. -3.95. What is the ratio of the Area (in %) of Canada in 1994 to that in 1995?
Offer a terse response. 0.94. What is the ratio of the Area (in %) in Afghanistan in 1994 to that in 1996?
Give a very brief answer. 1. What is the ratio of the Area (in %) in Canada in 1994 to that in 1996?
Make the answer very short. 0.9. What is the ratio of the Area (in %) of Cyprus in 1994 to that in 1996?
Offer a terse response. 0.98. What is the ratio of the Area (in %) in Afghanistan in 1994 to that in 1997?
Your response must be concise. 1. What is the ratio of the Area (in %) in Canada in 1994 to that in 1997?
Keep it short and to the point. 0.89. What is the ratio of the Area (in %) in Cyprus in 1994 to that in 1997?
Make the answer very short. 0.98. What is the ratio of the Area (in %) in Namibia in 1994 to that in 1997?
Ensure brevity in your answer.  1. What is the ratio of the Area (in %) in Afghanistan in 1994 to that in 1998?
Keep it short and to the point. 1. What is the ratio of the Area (in %) of Canada in 1994 to that in 1998?
Keep it short and to the point. 0.85. What is the ratio of the Area (in %) of Cyprus in 1994 to that in 1998?
Your answer should be very brief. 0.98. What is the ratio of the Area (in %) in Namibia in 1994 to that in 1998?
Provide a succinct answer. 1. What is the ratio of the Area (in %) in Afghanistan in 1994 to that in 1999?
Your response must be concise. 1. What is the ratio of the Area (in %) in Canada in 1994 to that in 1999?
Your answer should be very brief. 0.84. What is the ratio of the Area (in %) of Cyprus in 1994 to that in 1999?
Provide a short and direct response. 0.98. What is the ratio of the Area (in %) of Namibia in 1994 to that in 1999?
Give a very brief answer. 1. What is the ratio of the Area (in %) of Canada in 1994 to that in 2000?
Offer a very short reply. 0.69. What is the ratio of the Area (in %) in Cyprus in 1994 to that in 2000?
Ensure brevity in your answer.  0.27. What is the ratio of the Area (in %) of Namibia in 1994 to that in 2000?
Offer a terse response. 0.72. What is the ratio of the Area (in %) in Canada in 1994 to that in 2001?
Make the answer very short. 0.76. What is the ratio of the Area (in %) in Cyprus in 1994 to that in 2001?
Your answer should be compact. 0.98. What is the ratio of the Area (in %) in Namibia in 1994 to that in 2001?
Offer a terse response. 1. What is the ratio of the Area (in %) of Afghanistan in 1995 to that in 1996?
Offer a terse response. 1. What is the ratio of the Area (in %) in Canada in 1995 to that in 1996?
Your answer should be compact. 0.96. What is the ratio of the Area (in %) in Cyprus in 1995 to that in 1996?
Your answer should be very brief. 0.98. What is the ratio of the Area (in %) of Afghanistan in 1995 to that in 1997?
Make the answer very short. 1. What is the ratio of the Area (in %) in Canada in 1995 to that in 1997?
Provide a succinct answer. 0.95. What is the ratio of the Area (in %) in Cyprus in 1995 to that in 1997?
Your answer should be compact. 0.98. What is the ratio of the Area (in %) of Namibia in 1995 to that in 1997?
Provide a short and direct response. 1. What is the ratio of the Area (in %) of Canada in 1995 to that in 1998?
Provide a succinct answer. 0.91. What is the ratio of the Area (in %) of Cyprus in 1995 to that in 1998?
Your response must be concise. 0.98. What is the ratio of the Area (in %) of Canada in 1995 to that in 1999?
Your answer should be very brief. 0.89. What is the ratio of the Area (in %) in Cyprus in 1995 to that in 1999?
Give a very brief answer. 0.98. What is the ratio of the Area (in %) of Afghanistan in 1995 to that in 2000?
Offer a very short reply. 1. What is the ratio of the Area (in %) in Canada in 1995 to that in 2000?
Provide a short and direct response. 0.74. What is the ratio of the Area (in %) of Cyprus in 1995 to that in 2000?
Give a very brief answer. 0.27. What is the ratio of the Area (in %) of Namibia in 1995 to that in 2000?
Ensure brevity in your answer.  0.72. What is the ratio of the Area (in %) of Canada in 1995 to that in 2001?
Give a very brief answer. 0.82. What is the ratio of the Area (in %) of Cyprus in 1995 to that in 2001?
Keep it short and to the point. 0.98. What is the ratio of the Area (in %) of Afghanistan in 1996 to that in 1997?
Your answer should be compact. 1. What is the ratio of the Area (in %) of Canada in 1996 to that in 1997?
Offer a very short reply. 0.98. What is the ratio of the Area (in %) of Afghanistan in 1996 to that in 1998?
Provide a succinct answer. 1. What is the ratio of the Area (in %) in Canada in 1996 to that in 1998?
Keep it short and to the point. 0.94. What is the ratio of the Area (in %) of Cyprus in 1996 to that in 1998?
Give a very brief answer. 1. What is the ratio of the Area (in %) in Canada in 1996 to that in 1999?
Offer a very short reply. 0.93. What is the ratio of the Area (in %) of Namibia in 1996 to that in 1999?
Keep it short and to the point. 1. What is the ratio of the Area (in %) in Canada in 1996 to that in 2000?
Offer a terse response. 0.76. What is the ratio of the Area (in %) of Cyprus in 1996 to that in 2000?
Provide a succinct answer. 0.27. What is the ratio of the Area (in %) in Namibia in 1996 to that in 2000?
Ensure brevity in your answer.  0.72. What is the ratio of the Area (in %) in Afghanistan in 1996 to that in 2001?
Make the answer very short. 1. What is the ratio of the Area (in %) in Canada in 1996 to that in 2001?
Offer a very short reply. 0.85. What is the ratio of the Area (in %) in Namibia in 1996 to that in 2001?
Ensure brevity in your answer.  1. What is the ratio of the Area (in %) of Canada in 1997 to that in 1998?
Offer a very short reply. 0.96. What is the ratio of the Area (in %) in Canada in 1997 to that in 1999?
Give a very brief answer. 0.94. What is the ratio of the Area (in %) in Cyprus in 1997 to that in 1999?
Your response must be concise. 1. What is the ratio of the Area (in %) of Canada in 1997 to that in 2000?
Offer a terse response. 0.78. What is the ratio of the Area (in %) of Cyprus in 1997 to that in 2000?
Provide a succinct answer. 0.27. What is the ratio of the Area (in %) in Namibia in 1997 to that in 2000?
Give a very brief answer. 0.72. What is the ratio of the Area (in %) of Canada in 1997 to that in 2001?
Offer a very short reply. 0.86. What is the ratio of the Area (in %) in Cyprus in 1997 to that in 2001?
Make the answer very short. 1. What is the ratio of the Area (in %) of Namibia in 1997 to that in 2001?
Give a very brief answer. 1. What is the ratio of the Area (in %) in Canada in 1998 to that in 1999?
Make the answer very short. 0.99. What is the ratio of the Area (in %) in Cyprus in 1998 to that in 1999?
Offer a very short reply. 1. What is the ratio of the Area (in %) of Canada in 1998 to that in 2000?
Offer a very short reply. 0.81. What is the ratio of the Area (in %) in Cyprus in 1998 to that in 2000?
Offer a terse response. 0.27. What is the ratio of the Area (in %) in Namibia in 1998 to that in 2000?
Your response must be concise. 0.72. What is the ratio of the Area (in %) of Canada in 1998 to that in 2001?
Provide a short and direct response. 0.9. What is the ratio of the Area (in %) in Canada in 1999 to that in 2000?
Ensure brevity in your answer.  0.82. What is the ratio of the Area (in %) of Cyprus in 1999 to that in 2000?
Make the answer very short. 0.27. What is the ratio of the Area (in %) in Namibia in 1999 to that in 2000?
Provide a short and direct response. 0.72. What is the ratio of the Area (in %) in Afghanistan in 1999 to that in 2001?
Your answer should be very brief. 1. What is the ratio of the Area (in %) in Canada in 1999 to that in 2001?
Ensure brevity in your answer.  0.91. What is the ratio of the Area (in %) of Cyprus in 1999 to that in 2001?
Keep it short and to the point. 1. What is the ratio of the Area (in %) of Canada in 2000 to that in 2001?
Your answer should be very brief. 1.11. What is the ratio of the Area (in %) in Cyprus in 2000 to that in 2001?
Give a very brief answer. 3.68. What is the ratio of the Area (in %) in Namibia in 2000 to that in 2001?
Keep it short and to the point. 1.38. What is the difference between the highest and the second highest Area (in %) in Canada?
Make the answer very short. 0.68. What is the difference between the highest and the second highest Area (in %) of Cyprus?
Give a very brief answer. 28.12. What is the difference between the highest and the second highest Area (in %) in Namibia?
Give a very brief answer. 5.5. What is the difference between the highest and the lowest Area (in %) in Canada?
Your answer should be compact. 2.19. What is the difference between the highest and the lowest Area (in %) of Cyprus?
Make the answer very short. 28.33. What is the difference between the highest and the lowest Area (in %) in Namibia?
Keep it short and to the point. 5.54. 